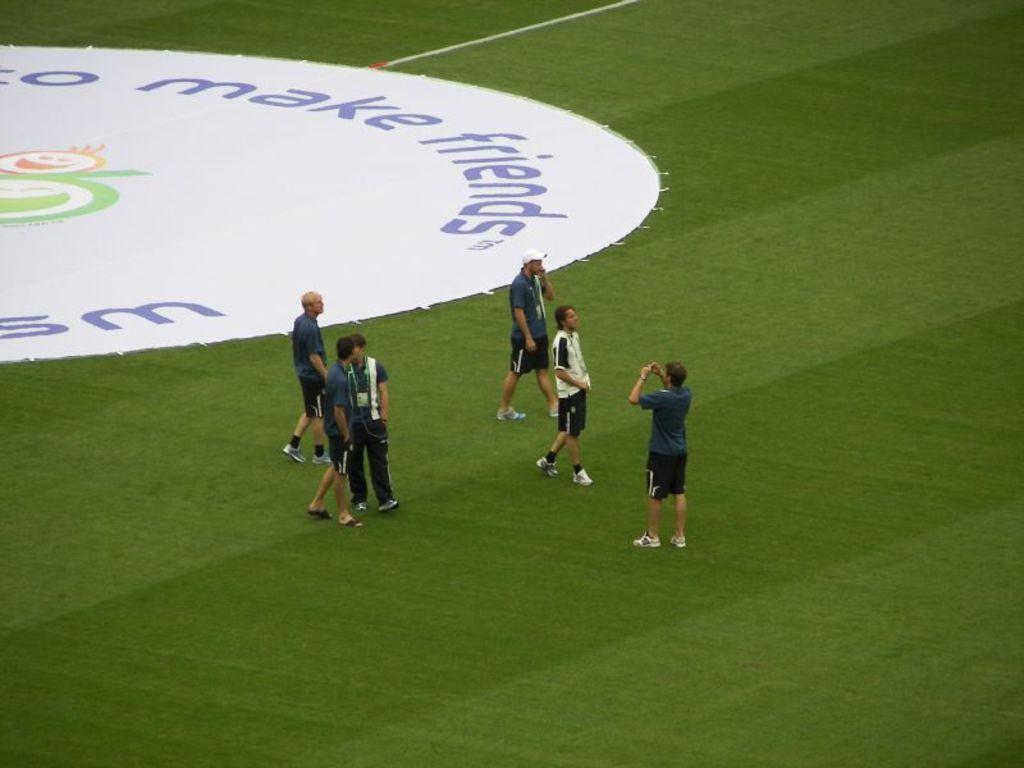What should one make?
Your answer should be very brief. Friends. What does the first word at the top say?
Ensure brevity in your answer.  Make. 